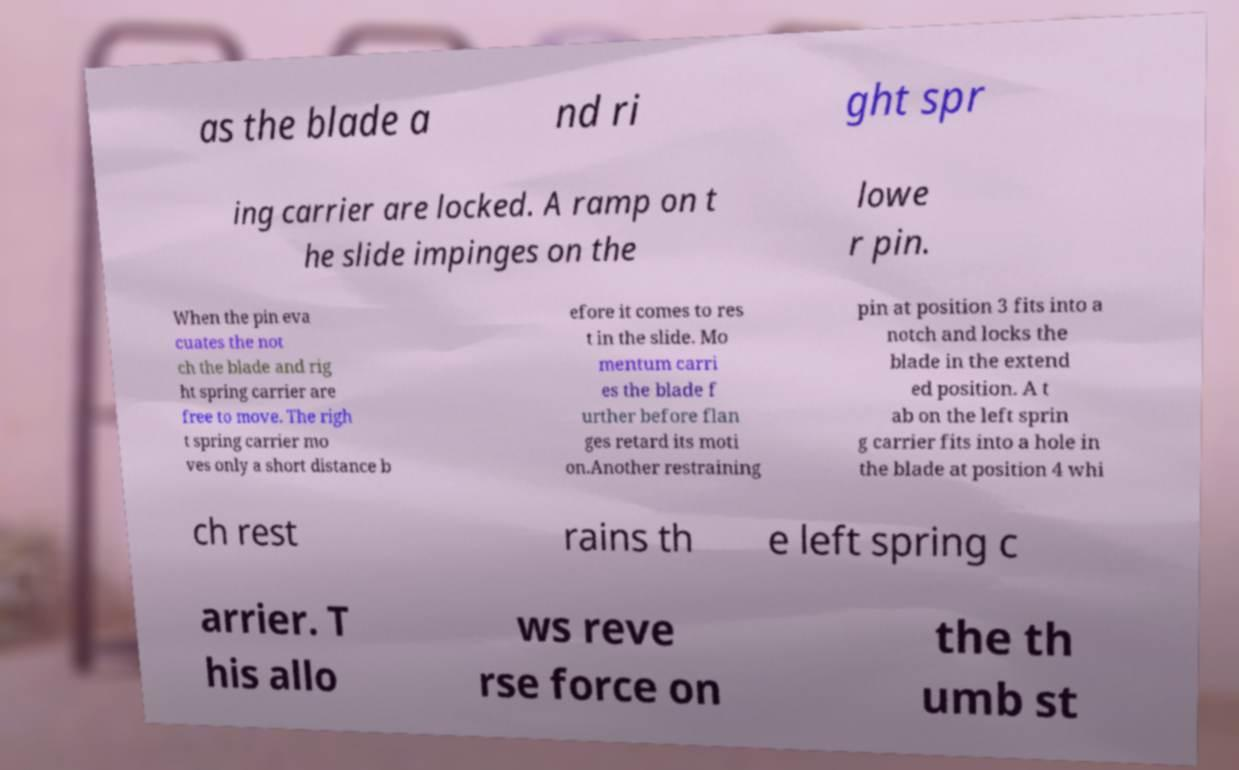Please read and relay the text visible in this image. What does it say? as the blade a nd ri ght spr ing carrier are locked. A ramp on t he slide impinges on the lowe r pin. When the pin eva cuates the not ch the blade and rig ht spring carrier are free to move. The righ t spring carrier mo ves only a short distance b efore it comes to res t in the slide. Mo mentum carri es the blade f urther before flan ges retard its moti on.Another restraining pin at position 3 fits into a notch and locks the blade in the extend ed position. A t ab on the left sprin g carrier fits into a hole in the blade at position 4 whi ch rest rains th e left spring c arrier. T his allo ws reve rse force on the th umb st 